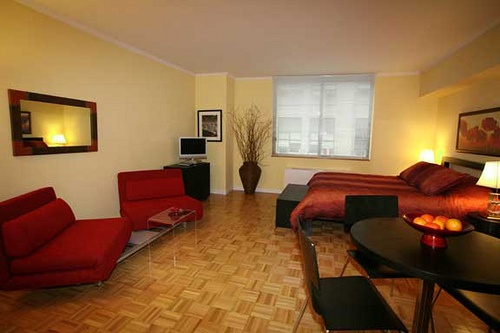Describe the objects in this image and their specific colors. I can see couch in olive, maroon, and brown tones, bed in olive, maroon, brown, and black tones, dining table in olive, black, and maroon tones, chair in olive, black, maroon, and brown tones, and couch in olive, maroon, and brown tones in this image. 